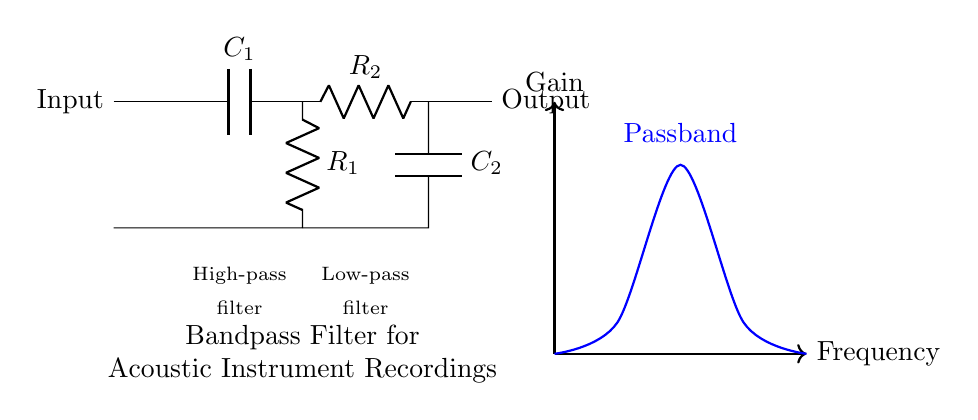What type of filter is represented in this circuit? The circuit is a bandpass filter, as indicated by the arrangement of components designed to allow a specific frequency range to pass through. The combination of high-pass and low-pass sections confirms its function as a bandpass filter.
Answer: Bandpass filter What components are used in the high-pass section? The high-pass section consists of a capacitor labeled C1 and a resistor labeled R1, which work together to block low frequencies while allowing higher frequencies to pass.
Answer: C1, R1 Which component is used to allow higher frequencies to pass? C1 is the capacitor in the high-pass filter section that allows higher frequencies while blocking lower frequencies, thereby determining the cutoff frequency for the high-pass functionality.
Answer: C1 How many different resistors are in the circuit? There are two resistors in the circuit: R1 for the high-pass section and R2 for the low-pass section, making a total of two resistors.
Answer: 2 What is the purpose of C2 in the circuit? C2 serves as the capacitor in the low-pass filter section, and its purpose is to block higher frequencies while allowing lower frequencies to pass through, contributing to the overall function of the bandpass filter.
Answer: To block higher frequencies What characteristics define the passband of this filter? The passband is defined by the frequency range that remains after the signal has passed through both the high-pass and low-pass filters, characterized by the gain being higher than the surrounding frequencies.
Answer: Gain and frequency range 